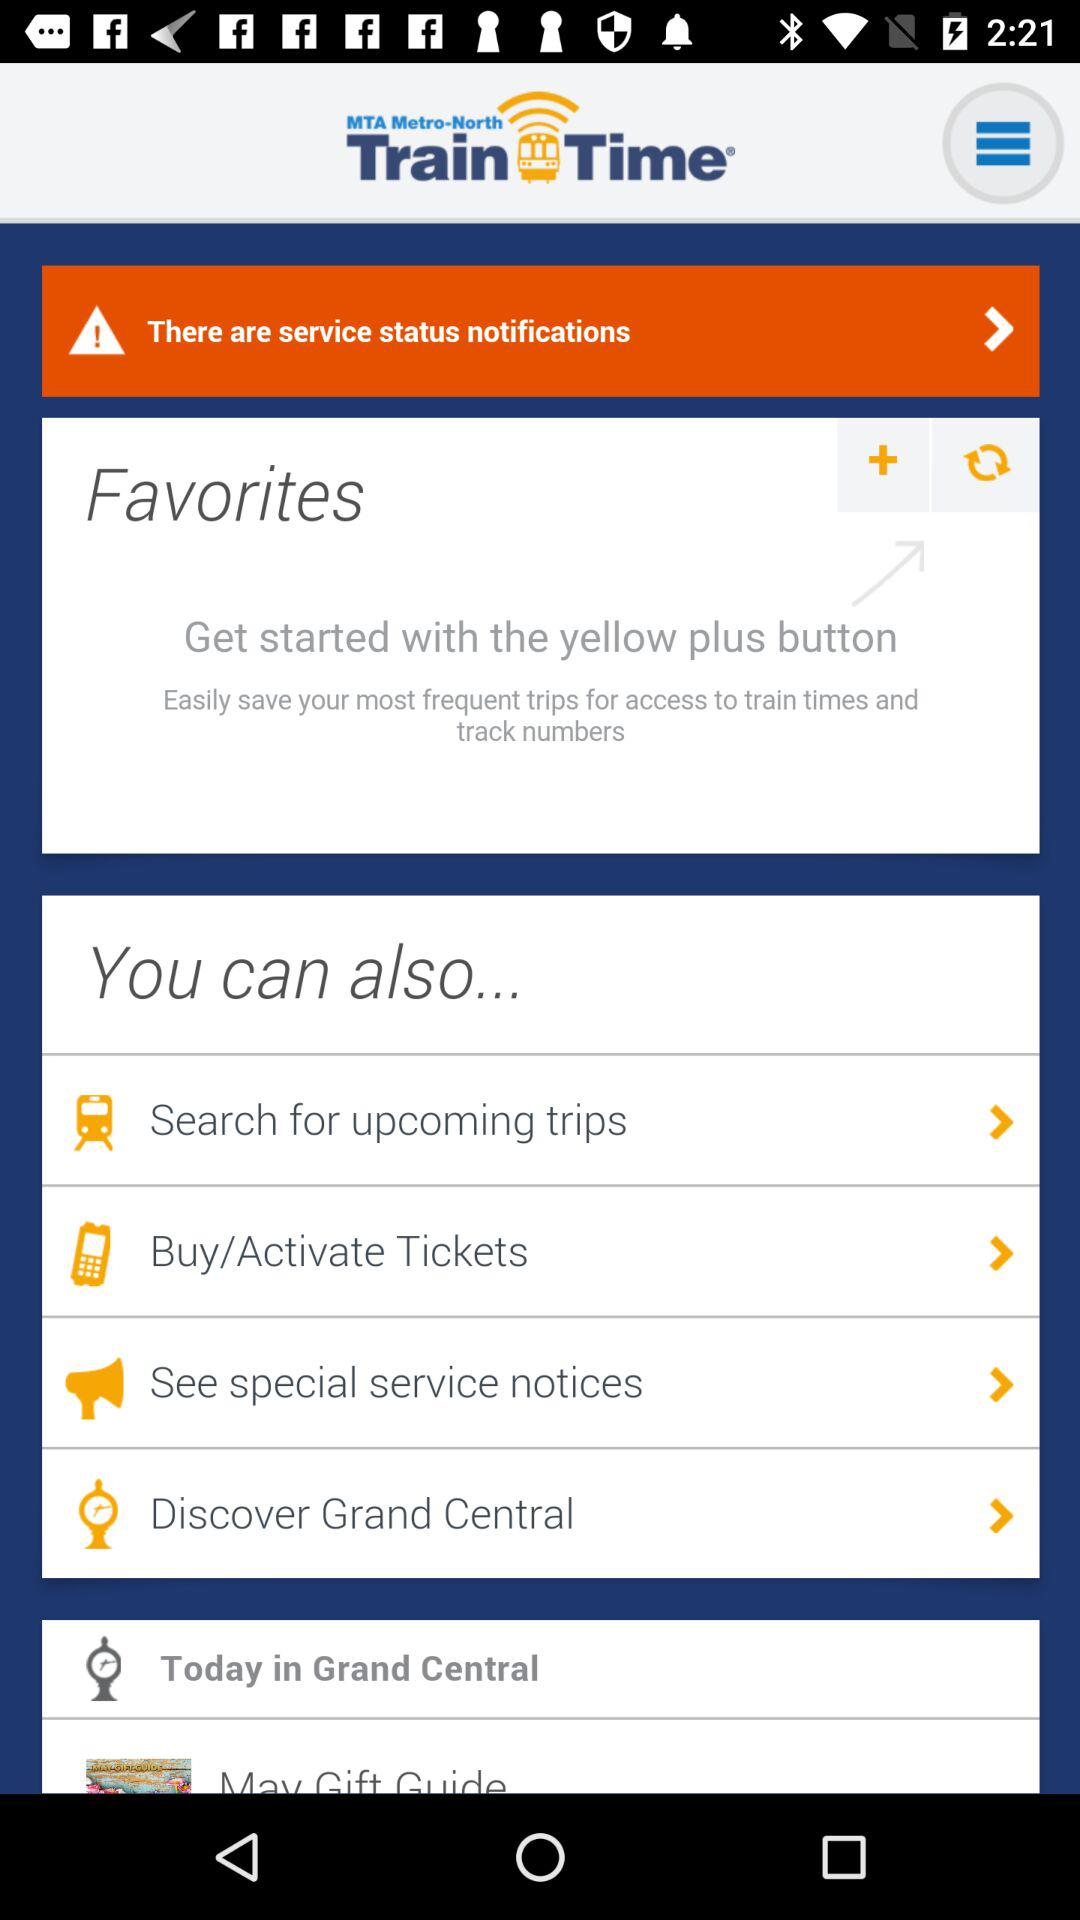What is the application name? The application name is "MTA Metro-North Train Time". 